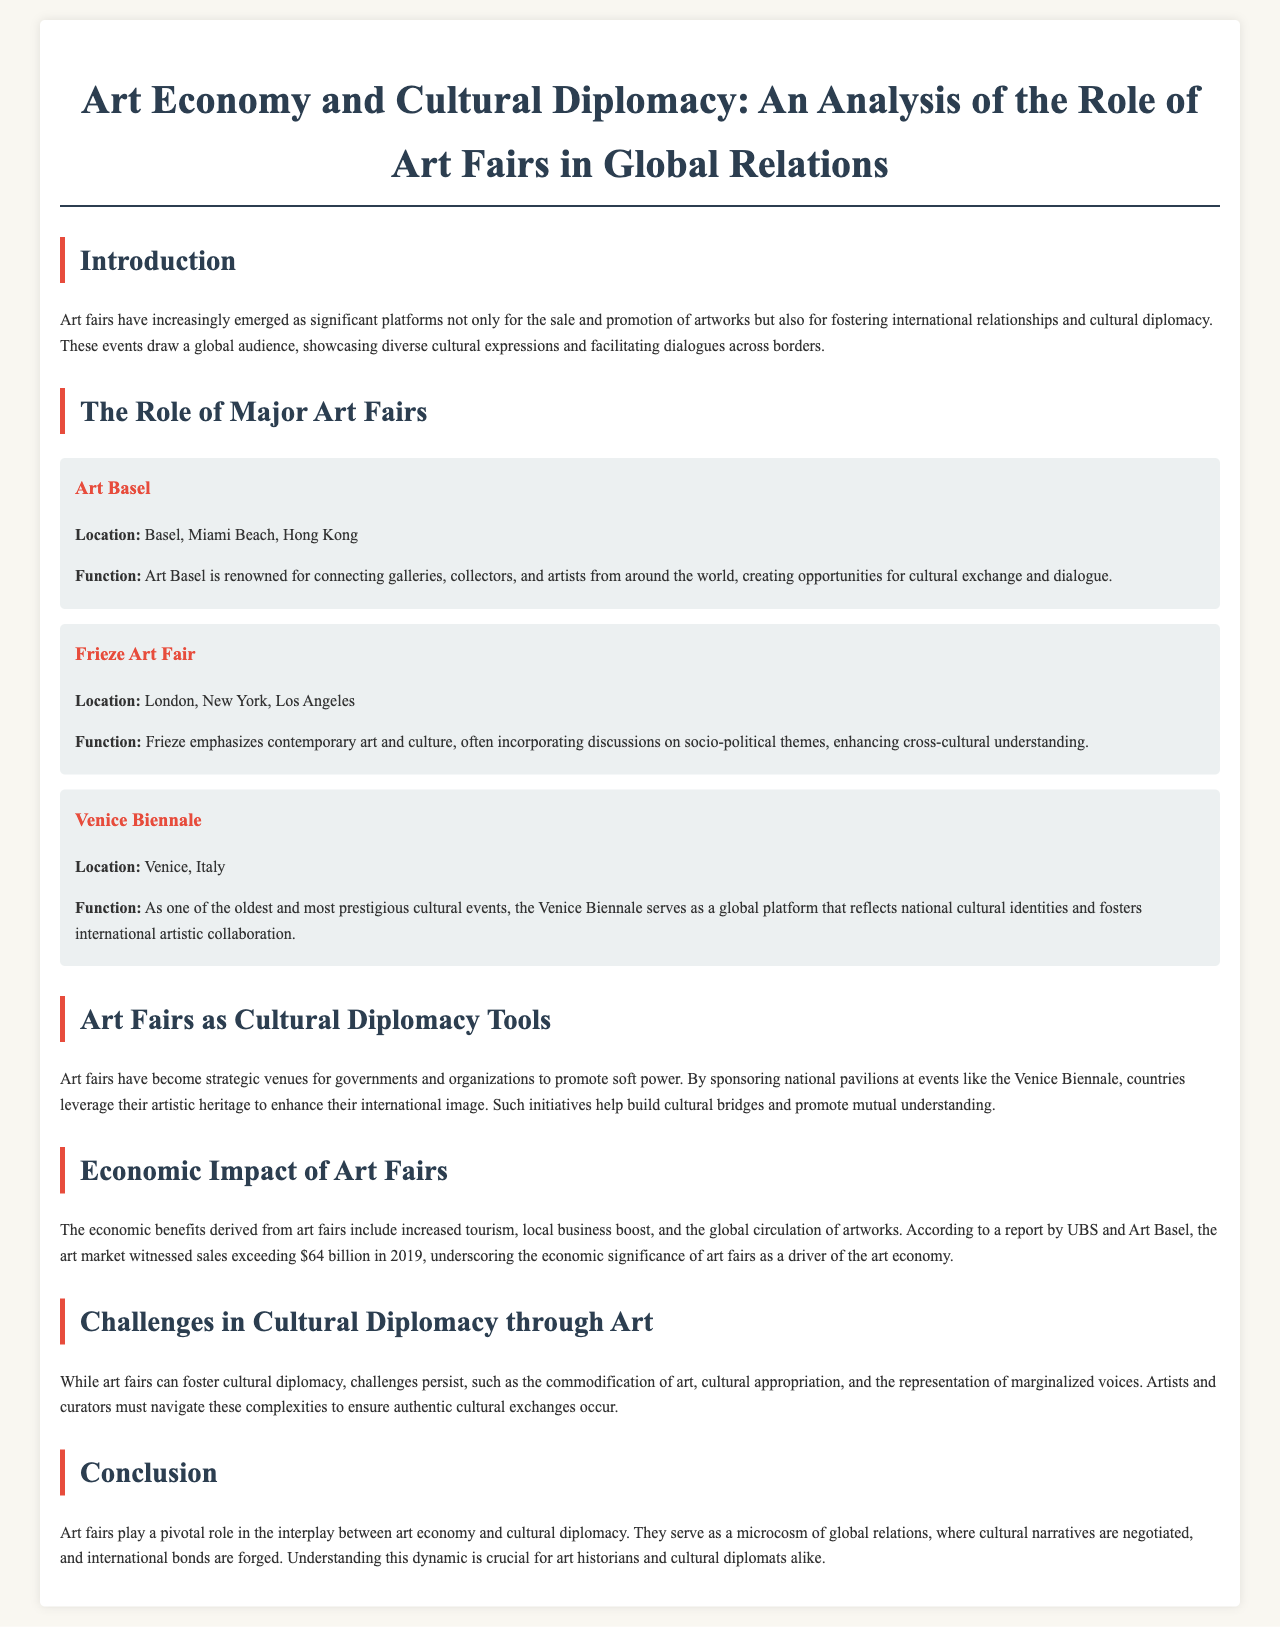What is the primary function of Art Basel? The primary function of Art Basel is to connect galleries, collectors, and artists from around the world, creating opportunities for cultural exchange and dialogue.
Answer: Connecting galleries, collectors, and artists Where is the Venice Biennale located? The Venice Biennale takes place in Venice, Italy.
Answer: Venice, Italy What economic figure is noted for the art market in 2019? The report mentions that the art market witnessed sales exceeding $64 billion in 2019.
Answer: $64 billion What are art fairs used for in cultural diplomacy? Art fairs are used as strategic venues for governments and organizations to promote soft power.
Answer: Strategic venues for soft power Name one challenge mentioned regarding cultural diplomacy through art. One challenge mentioned is the commodification of art.
Answer: Commodification of art Which art fair emphasizes contemporary art and includes socio-political discussions? The Frieze Art Fair emphasizes contemporary art and culture and incorporates socio-political discussions.
Answer: Frieze Art Fair What is one economic benefit of art fairs listed in the document? One economic benefit of art fairs is increased tourism.
Answer: Increased tourism Who benefits from sponsoring national pavilions at art fairs like the Venice Biennale? Countries benefit from sponsoring national pavilions to enhance their international image.
Answer: Countries 